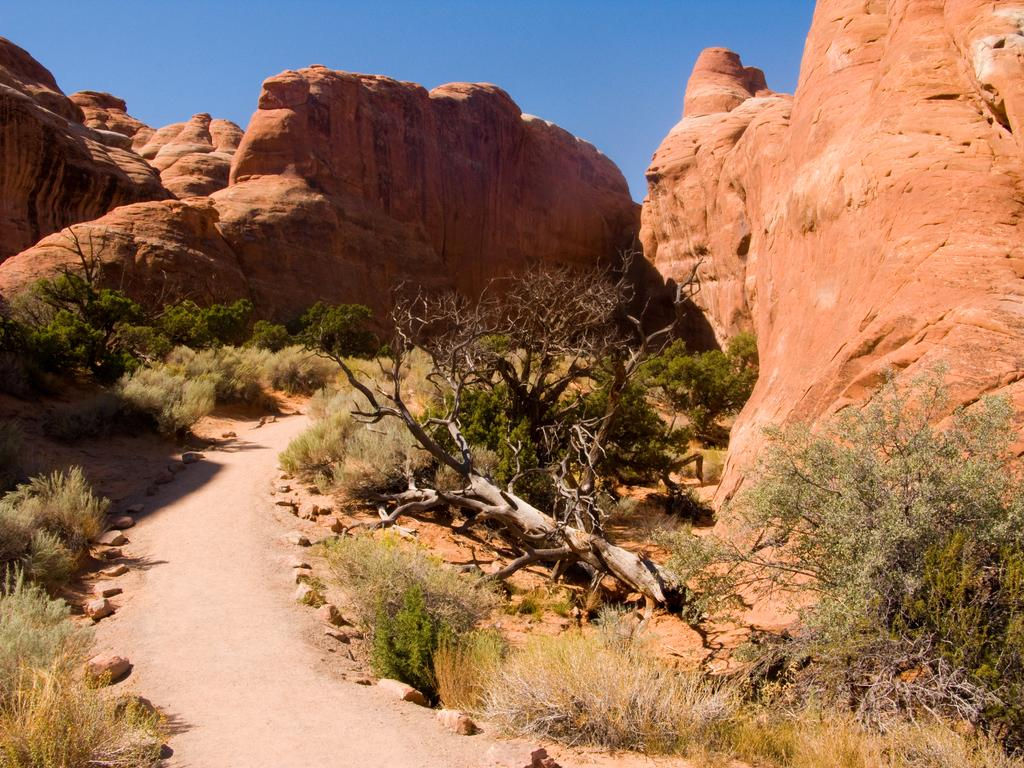What type of vegetation can be seen in the image? There are trees and grass in the image. What type of natural landform is visible in the image? There are mountains in the image. What part of the natural environment is visible in the image? The sky is visible in the image. Based on the presence of the sky and the absence of stars or a moon, when do you think the image was likely taken? The image was likely taken during the day. What type of cork can be seen hanging from the trees in the image? There is no cork present in the image; it features trees, grass, mountains, and the sky. How many icicles are visible on the mountains in the image? There are no icicles visible on the mountains in the image; it was likely taken during the day, and icicles typically form in colder temperatures. 